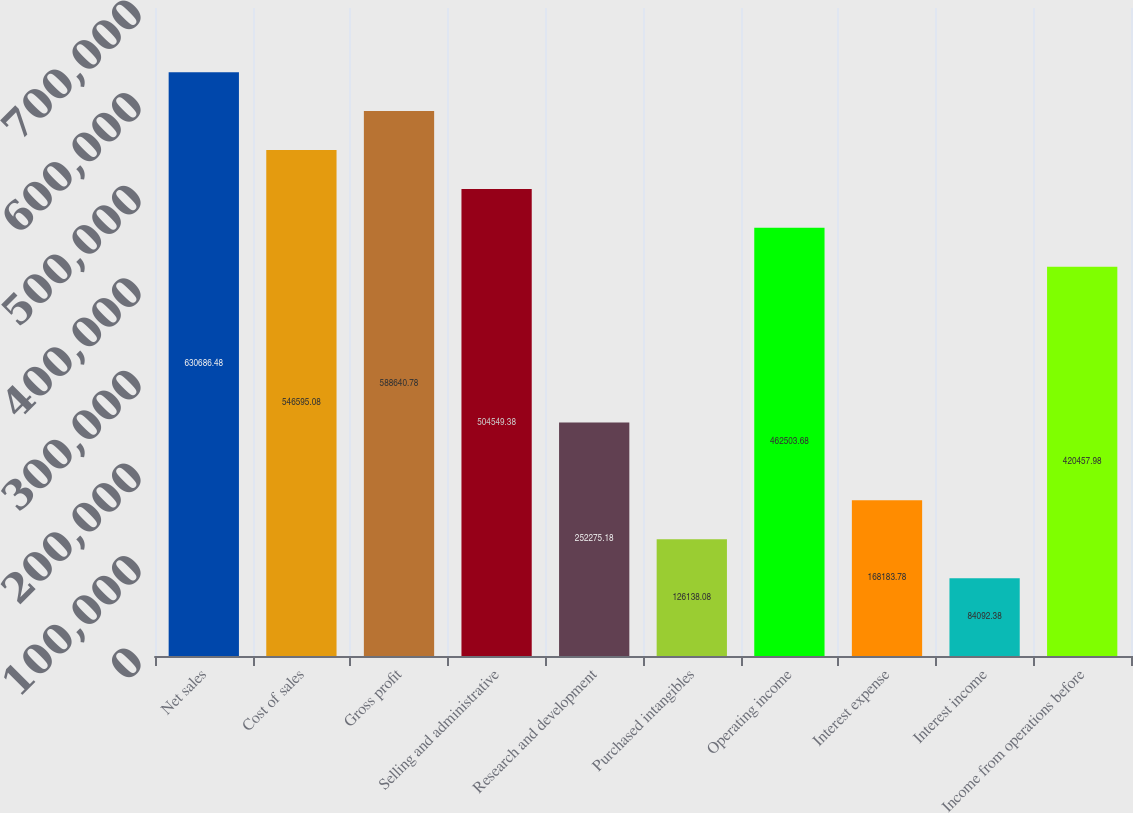Convert chart to OTSL. <chart><loc_0><loc_0><loc_500><loc_500><bar_chart><fcel>Net sales<fcel>Cost of sales<fcel>Gross profit<fcel>Selling and administrative<fcel>Research and development<fcel>Purchased intangibles<fcel>Operating income<fcel>Interest expense<fcel>Interest income<fcel>Income from operations before<nl><fcel>630686<fcel>546595<fcel>588641<fcel>504549<fcel>252275<fcel>126138<fcel>462504<fcel>168184<fcel>84092.4<fcel>420458<nl></chart> 